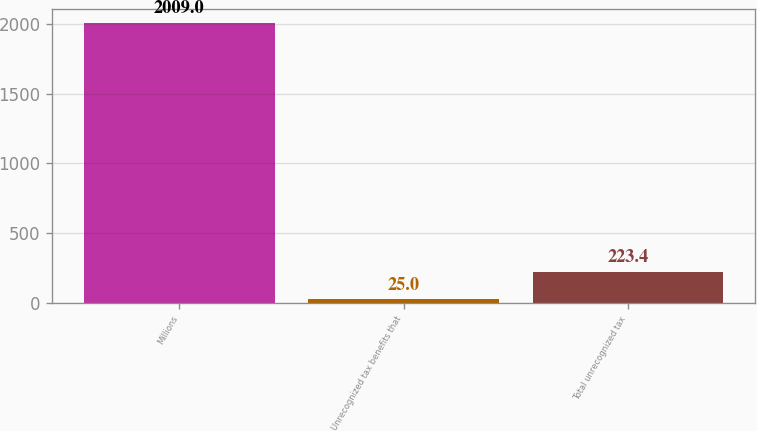<chart> <loc_0><loc_0><loc_500><loc_500><bar_chart><fcel>Millions<fcel>Unrecognized tax benefits that<fcel>Total unrecognized tax<nl><fcel>2009<fcel>25<fcel>223.4<nl></chart> 